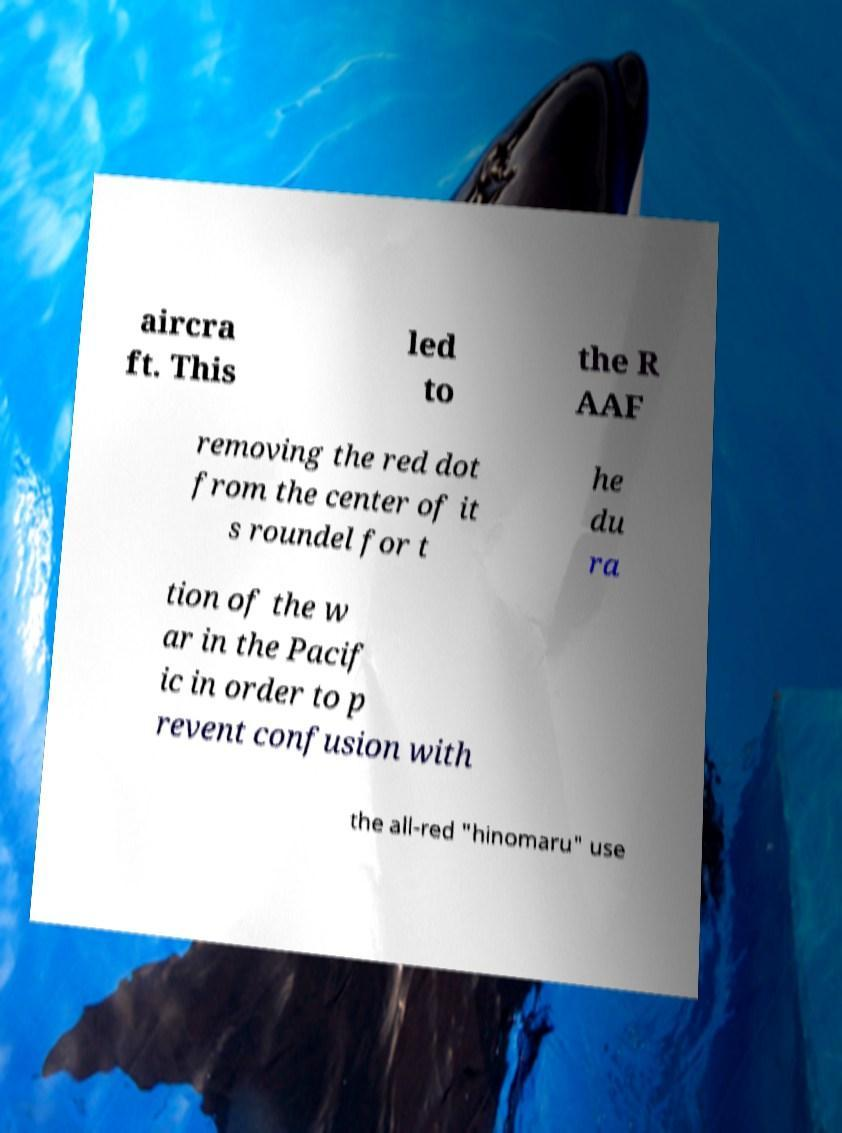Can you accurately transcribe the text from the provided image for me? aircra ft. This led to the R AAF removing the red dot from the center of it s roundel for t he du ra tion of the w ar in the Pacif ic in order to p revent confusion with the all-red "hinomaru" use 